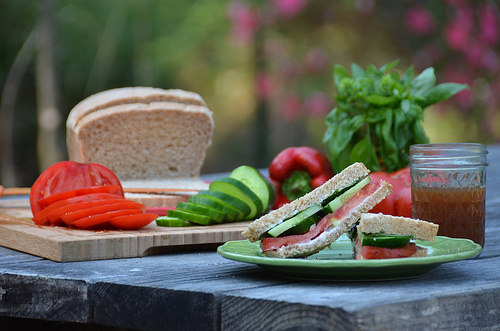<image>
Is there a sandwich on the table? Yes. Looking at the image, I can see the sandwich is positioned on top of the table, with the table providing support. 